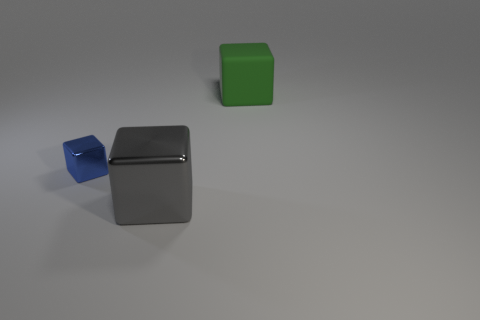Add 1 blue metallic cubes. How many objects exist? 4 Subtract all tiny metal things. Subtract all blue metallic blocks. How many objects are left? 1 Add 2 big green rubber cubes. How many big green rubber cubes are left? 3 Add 2 large rubber objects. How many large rubber objects exist? 3 Subtract 0 brown spheres. How many objects are left? 3 